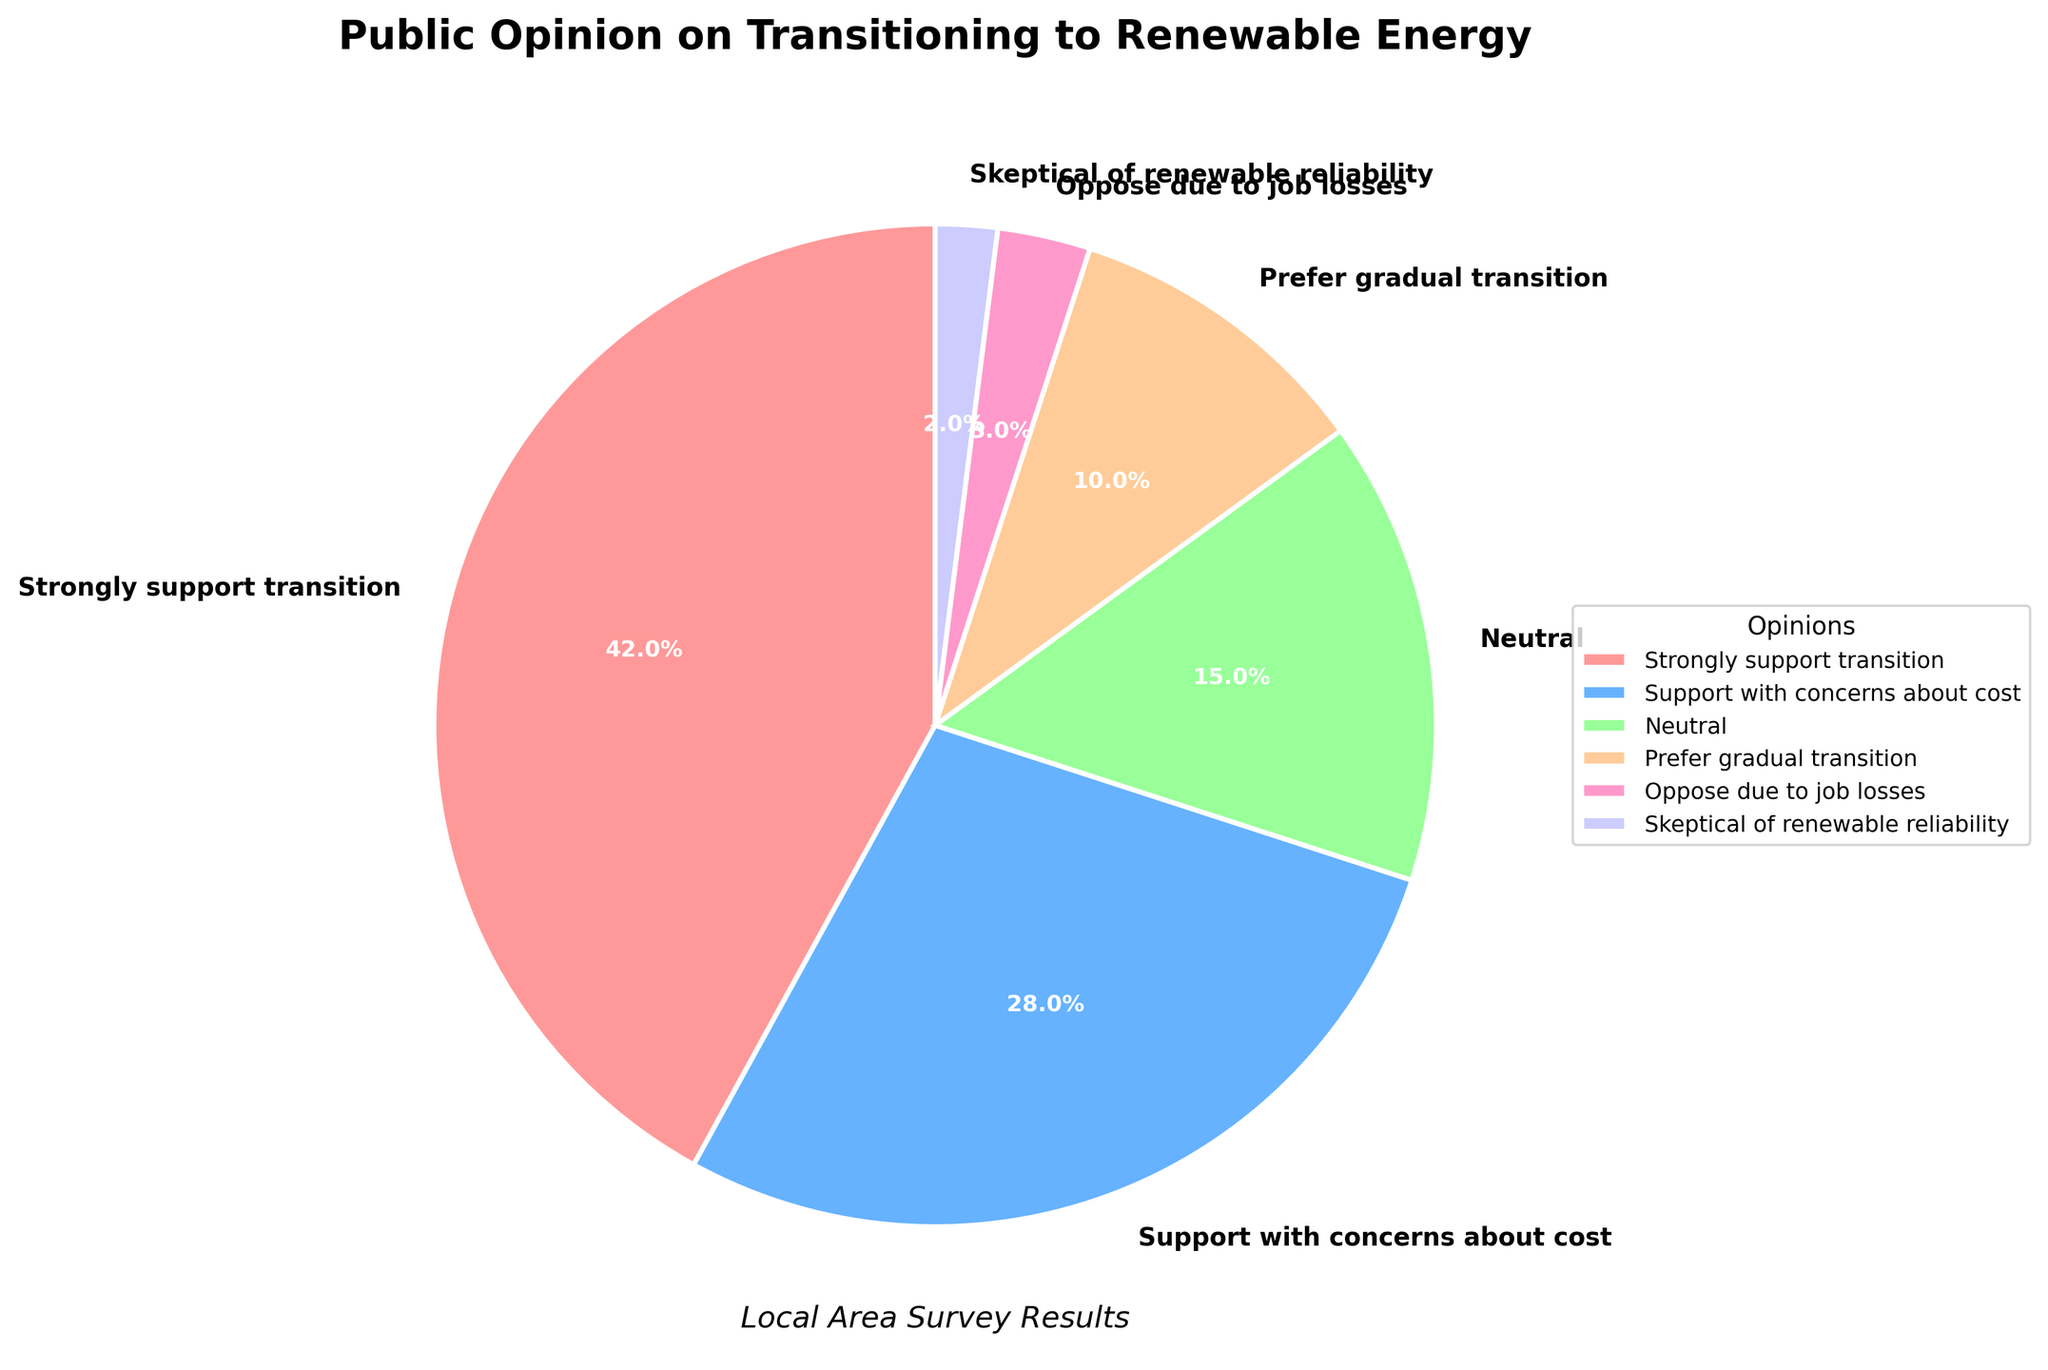What percentage of people are either strongly supporting or supporting the transition to renewable energy? To find the combined percentage of people who strongly support or support the transition with concerns about cost, add their respective percentages: 42% (strongly support) + 28% (support with concerns) = 70%.
Answer: 70% Which opinion category has the smallest percentage? By looking at all the opinion categories, the one with the smallest percentage is "Skeptical of renewable reliability" at 2%.
Answer: Skeptical of renewable reliability Are there more people who are neutral or who prefer a gradual transition to renewable energy? Compare the percentages of those who are neutral (15%) and those who prefer a gradual transition (10%). Since 15% is greater than 10%, more people are neutral about transitioning to renewable energy.
Answer: Neutral What's the total percentage of people who are either neutral or prefer a gradual transition? Add the percentages of people who are neutral (15%) and those who prefer a gradual transition (10%): 15% + 10% = 25%.
Answer: 25% How many opinions are above 10% in the chart? Identify the percentages of each opinion: 42%, 28%, 15%, and 10%. These four values are all greater than 10%. Therefore, there are 4 opinions above 10% in the chart.
Answer: 4 Compare the sum of percentages for those who oppose due to job losses and are skeptical of renewable reliability with those who prefer a gradual transition. Which is higher? Calculate the sum of percentages for those who oppose due to job losses (3%) and are skeptical of renewable reliability (2%): 3% + 2% = 5%. Compare it with the percentage of those who prefer a gradual transition (10%). Since 10% is greater than 5%, the latter is higher.
Answer: Prefer gradual transition What is the combined percentage of people who support the transition (strongly support and support with concerns) and those who are neutral? Add the percentages of strongly support (42%), support with concerns about cost (28%), and neutral (15%): 42% + 28% + 15% = 85%.
Answer: 85% Which segment of the pie chart has the largest wedge, and what is its percentage? The largest wedge in the pie chart corresponds to the "Strongly support transition" segment, which has a percentage of 42%.
Answer: Strongly support transition, 42% How much more (in percentage points) do people support the transition with concerns about cost than prefer a gradual transition? Subtract the percentage of people who prefer a gradual transition (10%) from those who support with concerns about cost (28%): 28% - 10% = 18%.
Answer: 18% What is the total percentage of opinions that are opposed or skeptical about the transition? Add the percentages for "Oppose due to job losses" (3%) and "Skeptical of renewable reliability" (2%): 3% + 2% = 5%.
Answer: 5% 